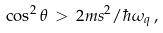<formula> <loc_0><loc_0><loc_500><loc_500>\cos ^ { 2 } \theta \, > \, 2 m s ^ { 2 } / \hbar { \omega } _ { q } \, ,</formula> 